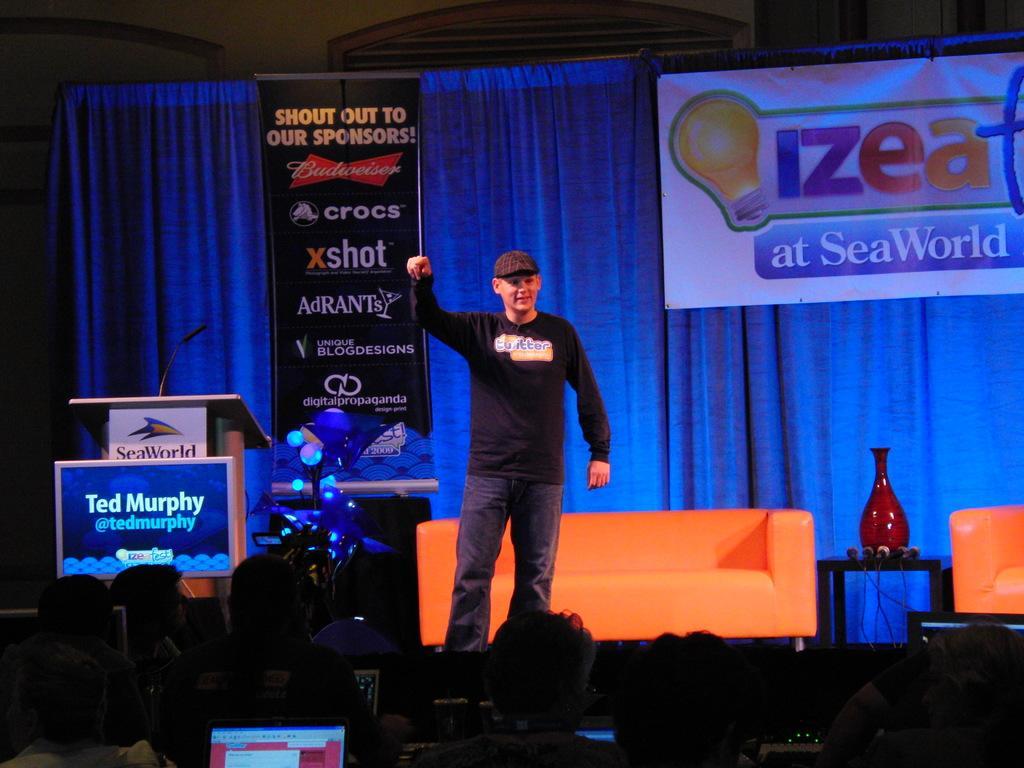Could you give a brief overview of what you see in this image? In the image we can see a man standing, wearing clothes and a cap. This is a podium, microphone, poster, curtains blue in color, sofa, vase and cable wires. There are even audiences, this is a laptop. 